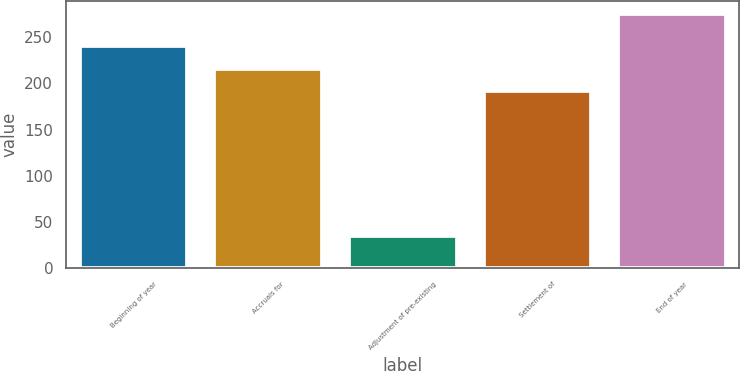<chart> <loc_0><loc_0><loc_500><loc_500><bar_chart><fcel>Beginning of year<fcel>Accruals for<fcel>Adjustment of pre-existing<fcel>Settlement of<fcel>End of year<nl><fcel>240<fcel>216<fcel>35<fcel>192<fcel>275<nl></chart> 